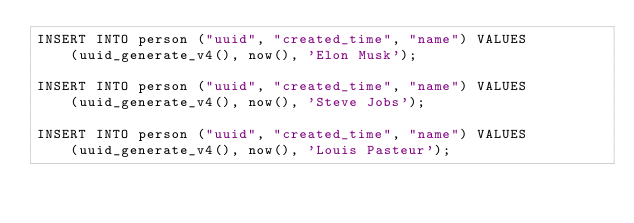Convert code to text. <code><loc_0><loc_0><loc_500><loc_500><_SQL_>INSERT INTO person ("uuid", "created_time", "name") VALUES
    (uuid_generate_v4(), now(), 'Elon Musk');

INSERT INTO person ("uuid", "created_time", "name") VALUES
    (uuid_generate_v4(), now(), 'Steve Jobs');

INSERT INTO person ("uuid", "created_time", "name") VALUES
    (uuid_generate_v4(), now(), 'Louis Pasteur');
</code> 